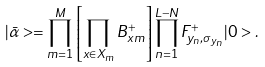Convert formula to latex. <formula><loc_0><loc_0><loc_500><loc_500>| \bar { \alpha } > = \prod _ { m = 1 } ^ { M } \left [ \prod _ { x \in X _ { m } } B _ { x m } ^ { + } \right ] \prod _ { n = 1 } ^ { L - N } F _ { y _ { n } , \sigma _ { y _ { n } } } ^ { + } | 0 > .</formula> 